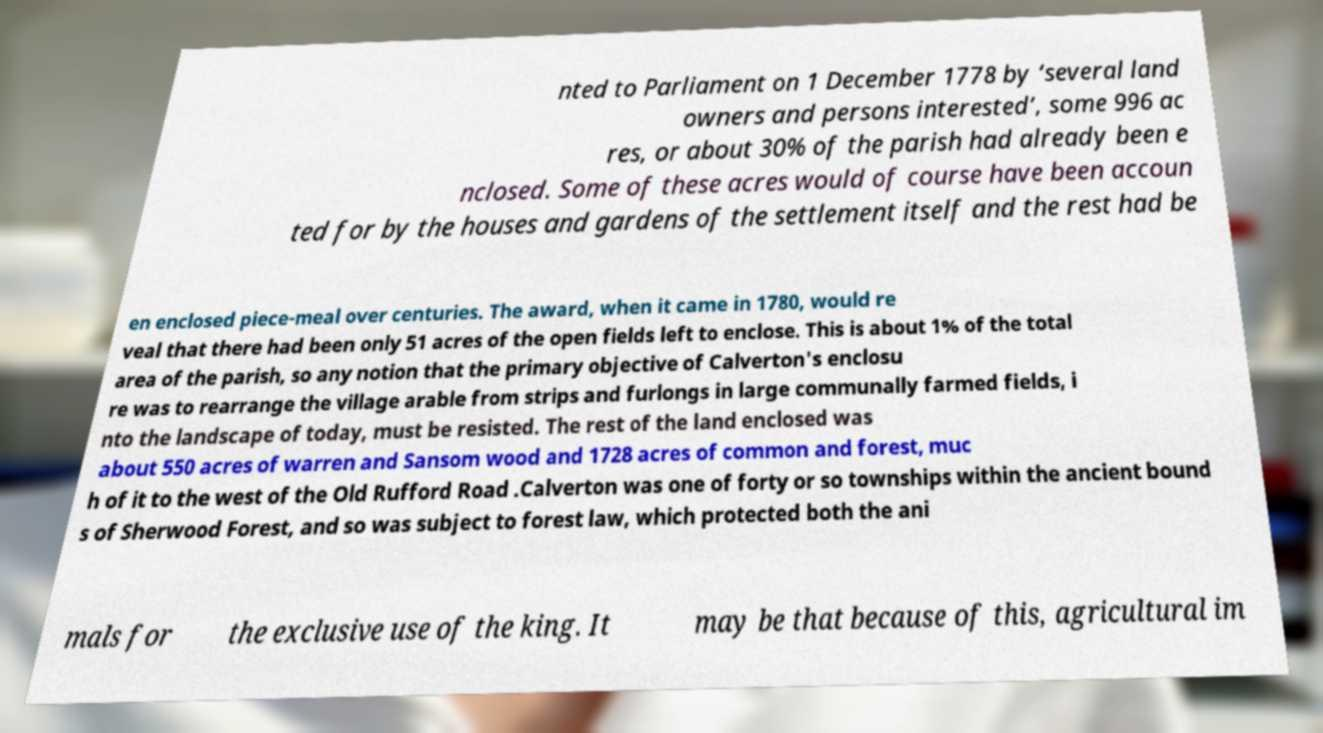Could you assist in decoding the text presented in this image and type it out clearly? nted to Parliament on 1 December 1778 by ‘several land owners and persons interested’, some 996 ac res, or about 30% of the parish had already been e nclosed. Some of these acres would of course have been accoun ted for by the houses and gardens of the settlement itself and the rest had be en enclosed piece-meal over centuries. The award, when it came in 1780, would re veal that there had been only 51 acres of the open fields left to enclose. This is about 1% of the total area of the parish, so any notion that the primary objective of Calverton's enclosu re was to rearrange the village arable from strips and furlongs in large communally farmed fields, i nto the landscape of today, must be resisted. The rest of the land enclosed was about 550 acres of warren and Sansom wood and 1728 acres of common and forest, muc h of it to the west of the Old Rufford Road .Calverton was one of forty or so townships within the ancient bound s of Sherwood Forest, and so was subject to forest law, which protected both the ani mals for the exclusive use of the king. It may be that because of this, agricultural im 